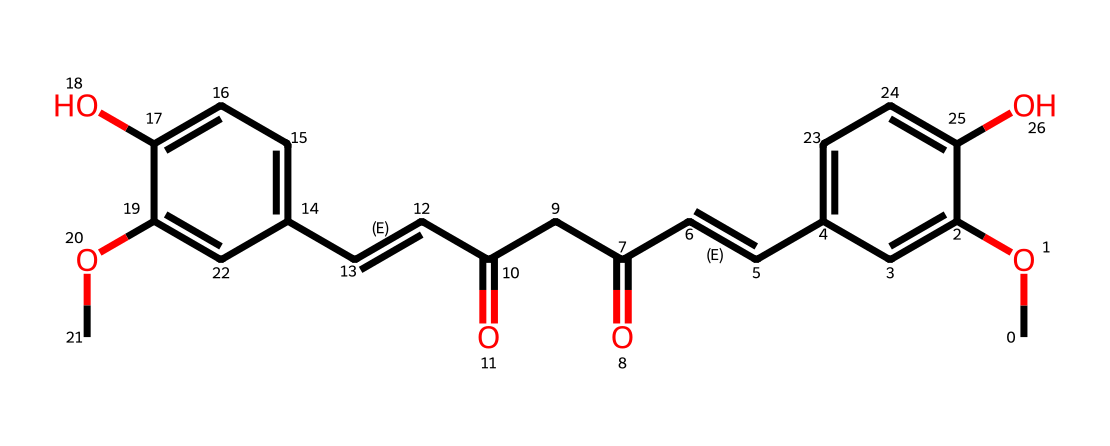What is the molecular formula of curcumin? To determine the molecular formula, you identify the types and counts of each atom in the structure represented by the SMILES notation. By analyzing the representation, you find there are 21 carbon atoms, 20 hydrogen atoms, and 6 oxygen atoms. Thus, the molecular formula is C21H20O6.
Answer: C21H20O6 How many hydroxyl groups are present in curcumin? The hydroxyl group consists of an -OH functional group. By examining the structure, you can locate two distinct -OH groups attached to the benzene rings in curcumin. Therefore, there are two hydroxyl groups present.
Answer: 2 What type of chemical compound is curcumin classified as? Curcumin contains multiple phenolic groups and is predominantly known for its polyphenolic structure due to its multiple aromatic rings. This characteristic classifies it primarily as a polyphenol.
Answer: polyphenol What is the highest oxidation state of oxygen in curcumin? In curcumin's structure, the oxygen atoms can exist in several oxidation states, but the carbonyl groups (C=O) represent one of the highest oxidation states for oxygen. There are two carbonyl groups in the structure. Thus, the highest oxidation state of oxygen is 2.
Answer: 2 Which part of the structure contributes to curcumin's yellow color? Curcumin's yellow color arises from the conjugated double bond system in the structure, particularly evident in the enone parts of the molecule. This system of alternating double and single bonds allows for the absorption of specific wavelengths of light, resulting in the distinct yellow color.
Answer: conjugated double bond system What is the total number of pi bonds in curcumin's structure? The pi bonds consist of double bonds where electrons are shared above and below the bond axis. Upon inspecting the structure, you can count the number of double bonds, which are six in total, accounting for all the pi bonds present in curcumin.
Answer: 6 